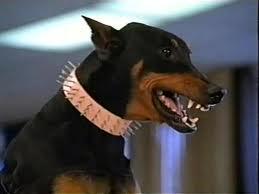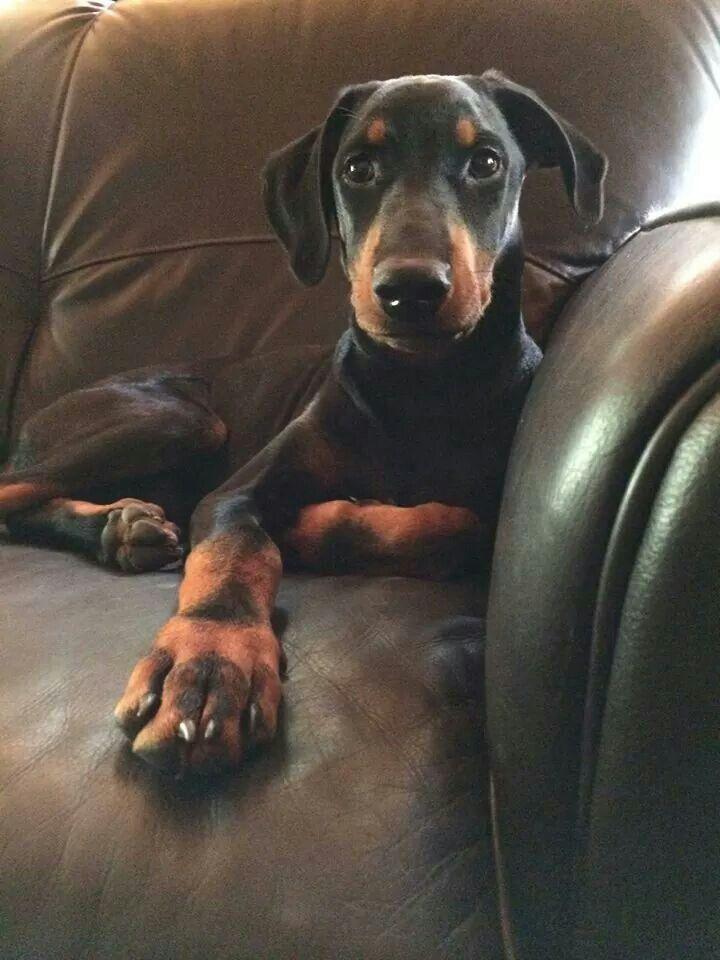The first image is the image on the left, the second image is the image on the right. Considering the images on both sides, is "The doberman on the left has upright ears and wears a collar, and the doberman on the right has floppy ears and no collar." valid? Answer yes or no. Yes. The first image is the image on the left, the second image is the image on the right. Analyze the images presented: Is the assertion "The dog in the image on the left is wearing a collar." valid? Answer yes or no. Yes. 